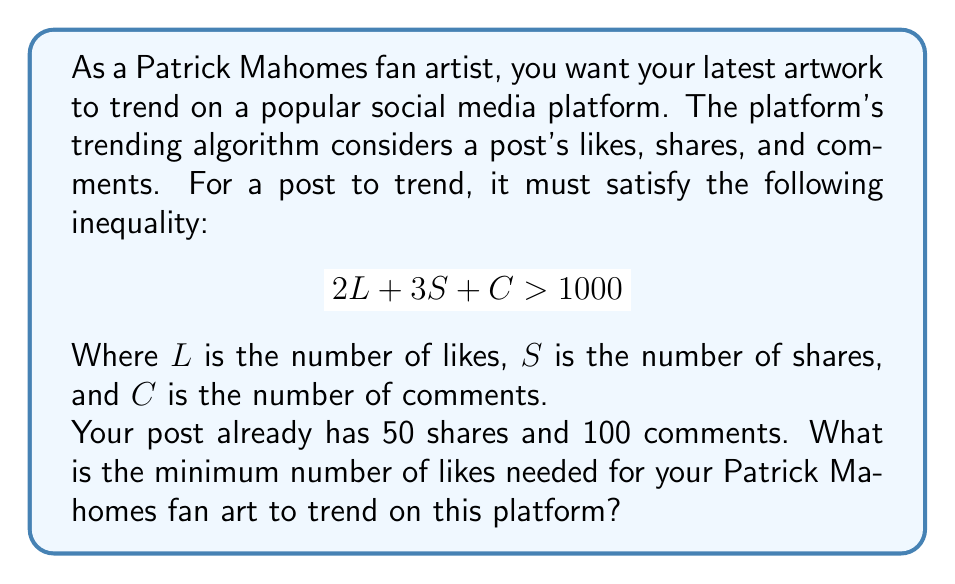Teach me how to tackle this problem. Let's approach this step-by-step:

1) We start with the given inequality:
   $$ 2L + 3S + C > 1000 $$

2) We know that $S = 50$ and $C = 100$. Let's substitute these values:
   $$ 2L + 3(50) + 100 > 1000 $$

3) Simplify the left side:
   $$ 2L + 150 + 100 > 1000 $$
   $$ 2L + 250 > 1000 $$

4) Subtract 250 from both sides:
   $$ 2L > 750 $$

5) Divide both sides by 2:
   $$ L > 375 $$

6) Since we need the minimum number of likes, and $L$ must be a whole number, we round up to the nearest integer.

Therefore, the minimum number of likes needed is 376.
Answer: 376 likes 